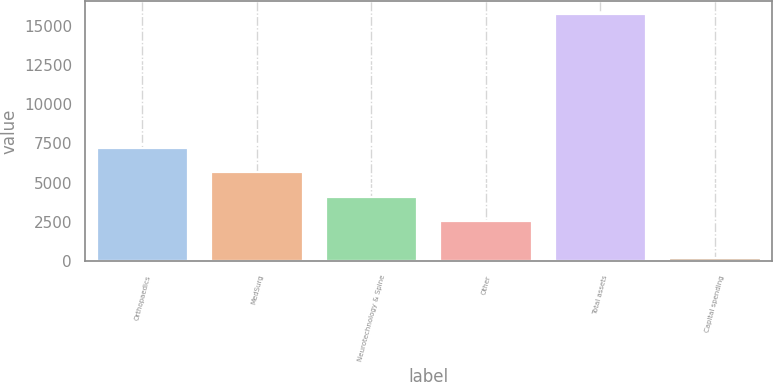Convert chart to OTSL. <chart><loc_0><loc_0><loc_500><loc_500><bar_chart><fcel>Orthopaedics<fcel>MedSurg<fcel>Neurotechnology & Spine<fcel>Other<fcel>Total assets<fcel>Capital spending<nl><fcel>7203.4<fcel>5648.6<fcel>4093.8<fcel>2539<fcel>15743<fcel>195<nl></chart> 